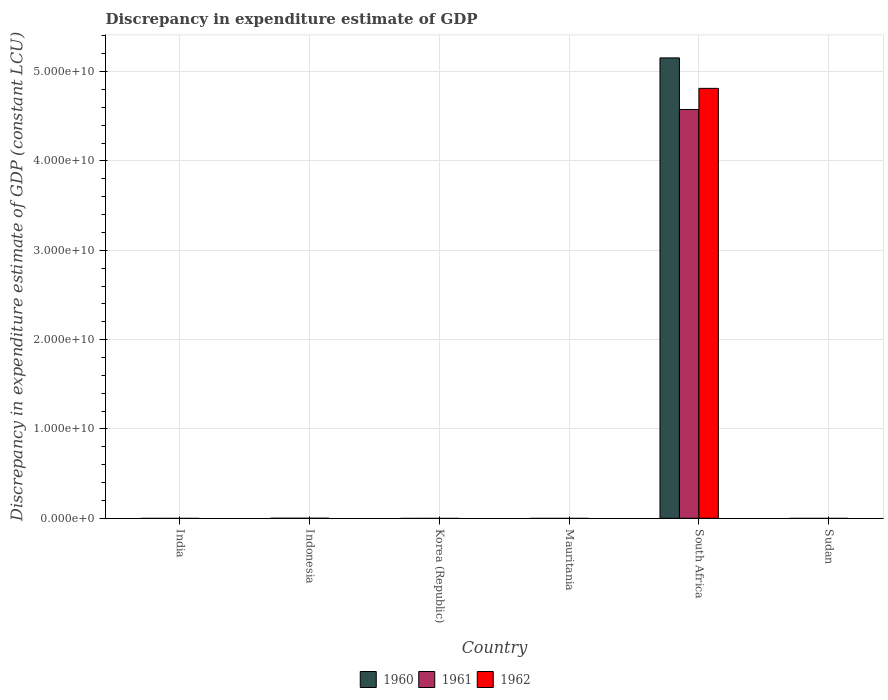What is the label of the 5th group of bars from the left?
Make the answer very short. South Africa. In how many cases, is the number of bars for a given country not equal to the number of legend labels?
Give a very brief answer. 5. What is the discrepancy in expenditure estimate of GDP in 1961 in Sudan?
Make the answer very short. 0. Across all countries, what is the maximum discrepancy in expenditure estimate of GDP in 1961?
Your answer should be very brief. 4.58e+1. In which country was the discrepancy in expenditure estimate of GDP in 1960 maximum?
Offer a terse response. South Africa. What is the total discrepancy in expenditure estimate of GDP in 1960 in the graph?
Provide a short and direct response. 5.15e+1. What is the difference between the discrepancy in expenditure estimate of GDP in 1961 in Mauritania and the discrepancy in expenditure estimate of GDP in 1960 in Korea (Republic)?
Make the answer very short. 0. What is the average discrepancy in expenditure estimate of GDP in 1962 per country?
Your response must be concise. 8.02e+09. In how many countries, is the discrepancy in expenditure estimate of GDP in 1961 greater than 2000000000 LCU?
Offer a very short reply. 1. What is the difference between the highest and the lowest discrepancy in expenditure estimate of GDP in 1960?
Provide a succinct answer. 5.15e+1. Is it the case that in every country, the sum of the discrepancy in expenditure estimate of GDP in 1960 and discrepancy in expenditure estimate of GDP in 1962 is greater than the discrepancy in expenditure estimate of GDP in 1961?
Keep it short and to the point. No. Are all the bars in the graph horizontal?
Keep it short and to the point. No. How many countries are there in the graph?
Offer a very short reply. 6. How many legend labels are there?
Your response must be concise. 3. How are the legend labels stacked?
Offer a very short reply. Horizontal. What is the title of the graph?
Give a very brief answer. Discrepancy in expenditure estimate of GDP. Does "2015" appear as one of the legend labels in the graph?
Your answer should be very brief. No. What is the label or title of the Y-axis?
Offer a terse response. Discrepancy in expenditure estimate of GDP (constant LCU). What is the Discrepancy in expenditure estimate of GDP (constant LCU) of 1961 in Indonesia?
Provide a short and direct response. 0. What is the Discrepancy in expenditure estimate of GDP (constant LCU) of 1962 in Indonesia?
Ensure brevity in your answer.  0. What is the Discrepancy in expenditure estimate of GDP (constant LCU) of 1961 in Korea (Republic)?
Keep it short and to the point. 0. What is the Discrepancy in expenditure estimate of GDP (constant LCU) of 1962 in Korea (Republic)?
Offer a very short reply. 0. What is the Discrepancy in expenditure estimate of GDP (constant LCU) in 1961 in Mauritania?
Your response must be concise. 0. What is the Discrepancy in expenditure estimate of GDP (constant LCU) in 1960 in South Africa?
Offer a very short reply. 5.15e+1. What is the Discrepancy in expenditure estimate of GDP (constant LCU) of 1961 in South Africa?
Your response must be concise. 4.58e+1. What is the Discrepancy in expenditure estimate of GDP (constant LCU) in 1962 in South Africa?
Make the answer very short. 4.81e+1. What is the Discrepancy in expenditure estimate of GDP (constant LCU) of 1962 in Sudan?
Your answer should be compact. 0. Across all countries, what is the maximum Discrepancy in expenditure estimate of GDP (constant LCU) in 1960?
Give a very brief answer. 5.15e+1. Across all countries, what is the maximum Discrepancy in expenditure estimate of GDP (constant LCU) in 1961?
Your answer should be compact. 4.58e+1. Across all countries, what is the maximum Discrepancy in expenditure estimate of GDP (constant LCU) in 1962?
Your answer should be compact. 4.81e+1. What is the total Discrepancy in expenditure estimate of GDP (constant LCU) in 1960 in the graph?
Your answer should be very brief. 5.15e+1. What is the total Discrepancy in expenditure estimate of GDP (constant LCU) of 1961 in the graph?
Offer a terse response. 4.58e+1. What is the total Discrepancy in expenditure estimate of GDP (constant LCU) in 1962 in the graph?
Provide a succinct answer. 4.81e+1. What is the average Discrepancy in expenditure estimate of GDP (constant LCU) of 1960 per country?
Ensure brevity in your answer.  8.59e+09. What is the average Discrepancy in expenditure estimate of GDP (constant LCU) of 1961 per country?
Provide a succinct answer. 7.63e+09. What is the average Discrepancy in expenditure estimate of GDP (constant LCU) of 1962 per country?
Make the answer very short. 8.02e+09. What is the difference between the Discrepancy in expenditure estimate of GDP (constant LCU) of 1960 and Discrepancy in expenditure estimate of GDP (constant LCU) of 1961 in South Africa?
Provide a short and direct response. 5.78e+09. What is the difference between the Discrepancy in expenditure estimate of GDP (constant LCU) in 1960 and Discrepancy in expenditure estimate of GDP (constant LCU) in 1962 in South Africa?
Provide a short and direct response. 3.41e+09. What is the difference between the Discrepancy in expenditure estimate of GDP (constant LCU) in 1961 and Discrepancy in expenditure estimate of GDP (constant LCU) in 1962 in South Africa?
Provide a succinct answer. -2.37e+09. What is the difference between the highest and the lowest Discrepancy in expenditure estimate of GDP (constant LCU) in 1960?
Your answer should be compact. 5.15e+1. What is the difference between the highest and the lowest Discrepancy in expenditure estimate of GDP (constant LCU) in 1961?
Ensure brevity in your answer.  4.58e+1. What is the difference between the highest and the lowest Discrepancy in expenditure estimate of GDP (constant LCU) in 1962?
Provide a succinct answer. 4.81e+1. 